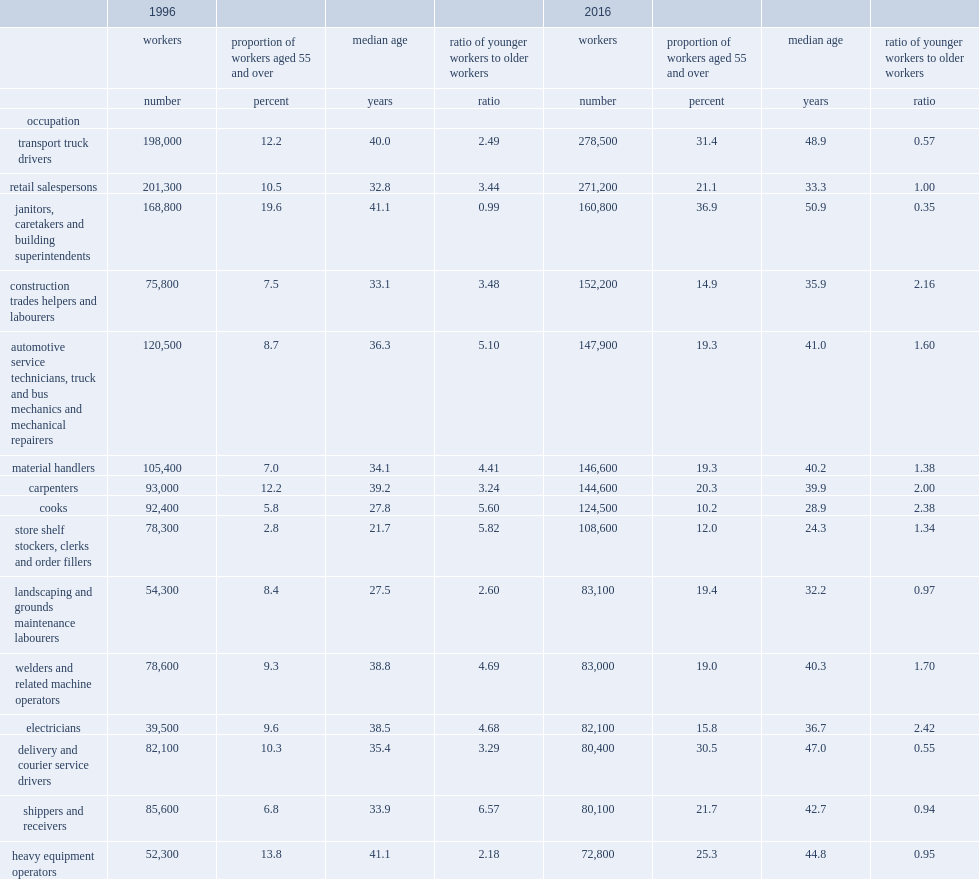What is the number of transport truck drivers in 2016? 278500.0. What is the percentage of men aged 55 and over among transport truck drivers in 2016? 31.4. What is the percentage of men aged 55 and over among transport truck drivers in 1996? 12.2. What is the ratio of younger transport truck drivers to older transport truck drivers in 1996? 2.49. What is the ratio of younger transport truck drivers to older transport truck drivers in 2016? 0.57. What is the percentage of men aged 55 and over among janitors, caretakers and building superintendents in 2016? 36.9. What is the percentage of men aged 55 and over among janitors, caretakers and building superintendents in 1996? 19.6. What is the percentage of male cooks aged 55 and over among all cooks in 2016? 10.2. What is the ratio of younger cooks to older cooks in 2016? 2.38. 